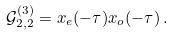<formula> <loc_0><loc_0><loc_500><loc_500>\mathcal { G } _ { 2 , 2 } ^ { ( 3 ) } = x _ { e } ( - \tau ) x _ { o } ( - \tau ) \, .</formula> 